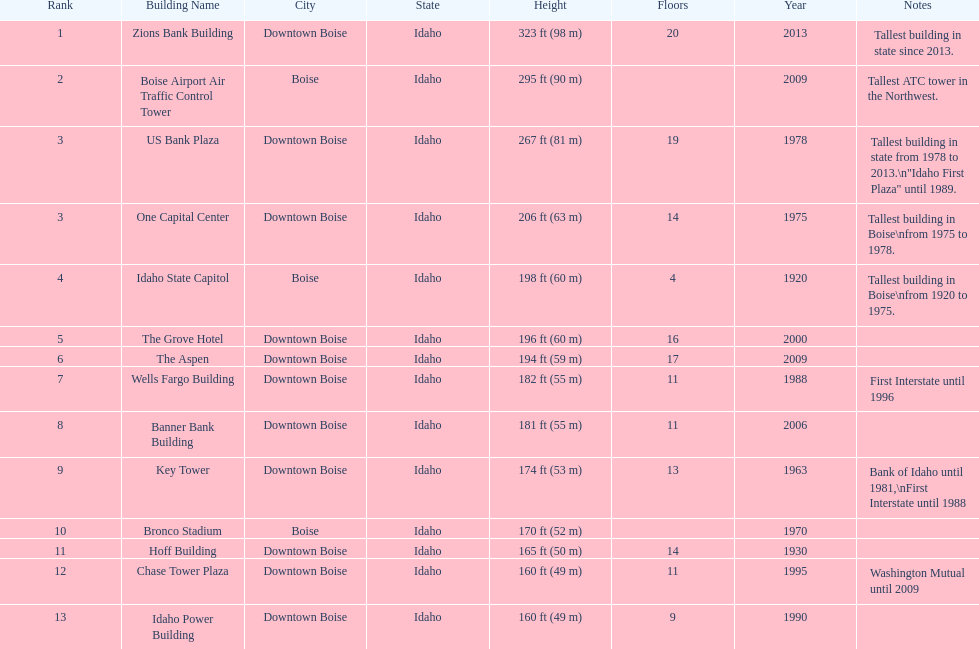Can you give me this table as a dict? {'header': ['Rank', 'Building Name', 'City', 'State', 'Height', 'Floors', 'Year', 'Notes'], 'rows': [['1', 'Zions Bank Building', 'Downtown Boise', 'Idaho', '323\xa0ft (98\xa0m)', '20', '2013', 'Tallest building in state since 2013.'], ['2', 'Boise Airport Air Traffic Control Tower', 'Boise', 'Idaho', '295\xa0ft (90\xa0m)', '', '2009', 'Tallest ATC tower in the Northwest.'], ['3', 'US Bank Plaza', 'Downtown Boise', 'Idaho', '267\xa0ft (81\xa0m)', '19', '1978', 'Tallest building in state from 1978 to 2013.\\n"Idaho First Plaza" until 1989.'], ['3', 'One Capital Center', 'Downtown Boise', 'Idaho', '206\xa0ft (63\xa0m)', '14', '1975', 'Tallest building in Boise\\nfrom 1975 to 1978.'], ['4', 'Idaho State Capitol', 'Boise', 'Idaho', '198\xa0ft (60\xa0m)', '4', '1920', 'Tallest building in Boise\\nfrom 1920 to 1975.'], ['5', 'The Grove Hotel', 'Downtown Boise', 'Idaho', '196\xa0ft (60\xa0m)', '16', '2000', ''], ['6', 'The Aspen', 'Downtown Boise', 'Idaho', '194\xa0ft (59\xa0m)', '17', '2009', ''], ['7', 'Wells Fargo Building', 'Downtown Boise', 'Idaho', '182\xa0ft (55\xa0m)', '11', '1988', 'First Interstate until 1996'], ['8', 'Banner Bank Building', 'Downtown Boise', 'Idaho', '181\xa0ft (55\xa0m)', '11', '2006', ''], ['9', 'Key Tower', 'Downtown Boise', 'Idaho', '174\xa0ft (53\xa0m)', '13', '1963', 'Bank of Idaho until 1981,\\nFirst Interstate until 1988'], ['10', 'Bronco Stadium', 'Boise', 'Idaho', '170\xa0ft (52\xa0m)', '', '1970', ''], ['11', 'Hoff Building', 'Downtown Boise', 'Idaho', '165\xa0ft (50\xa0m)', '14', '1930', ''], ['12', 'Chase Tower Plaza', 'Downtown Boise', 'Idaho', '160\xa0ft (49\xa0m)', '11', '1995', 'Washington Mutual until 2009'], ['13', 'Idaho Power Building', 'Downtown Boise', 'Idaho', '160\xa0ft (49\xa0m)', '9', '1990', '']]} What is the name of the last building on this chart? Idaho Power Building. 